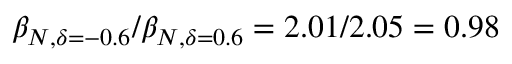<formula> <loc_0><loc_0><loc_500><loc_500>\beta _ { N , \delta = - 0 . 6 } / \beta _ { N , \delta = 0 . 6 } = 2 . 0 1 / 2 . 0 5 = 0 . 9 8</formula> 